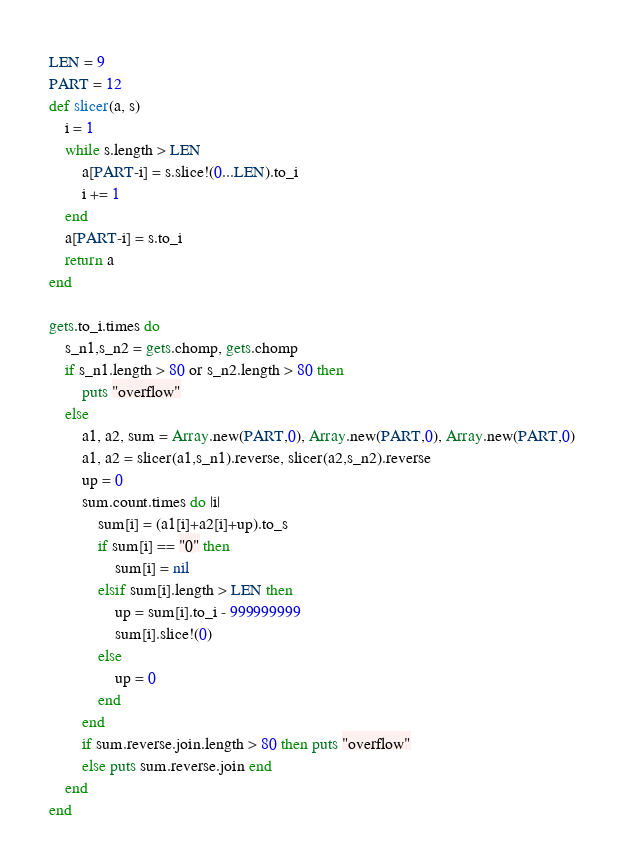Convert code to text. <code><loc_0><loc_0><loc_500><loc_500><_Ruby_>LEN = 9
PART = 12
def slicer(a, s)
	i = 1
	while s.length > LEN
		a[PART-i] = s.slice!(0...LEN).to_i
		i += 1
	end
	a[PART-i] = s.to_i
	return a
end

gets.to_i.times do
	s_n1,s_n2 = gets.chomp, gets.chomp
	if s_n1.length > 80 or s_n2.length > 80 then
		puts "overflow"
	else
		a1, a2, sum = Array.new(PART,0), Array.new(PART,0), Array.new(PART,0)
		a1, a2 = slicer(a1,s_n1).reverse, slicer(a2,s_n2).reverse
		up = 0
		sum.count.times do |i|
			sum[i] = (a1[i]+a2[i]+up).to_s
			if sum[i] == "0" then
				sum[i] = nil
			elsif sum[i].length > LEN then
				up = sum[i].to_i - 999999999
				sum[i].slice!(0)
			else
				up = 0
			end
		end
		if sum.reverse.join.length > 80 then puts "overflow"
		else puts sum.reverse.join end
	end
end</code> 